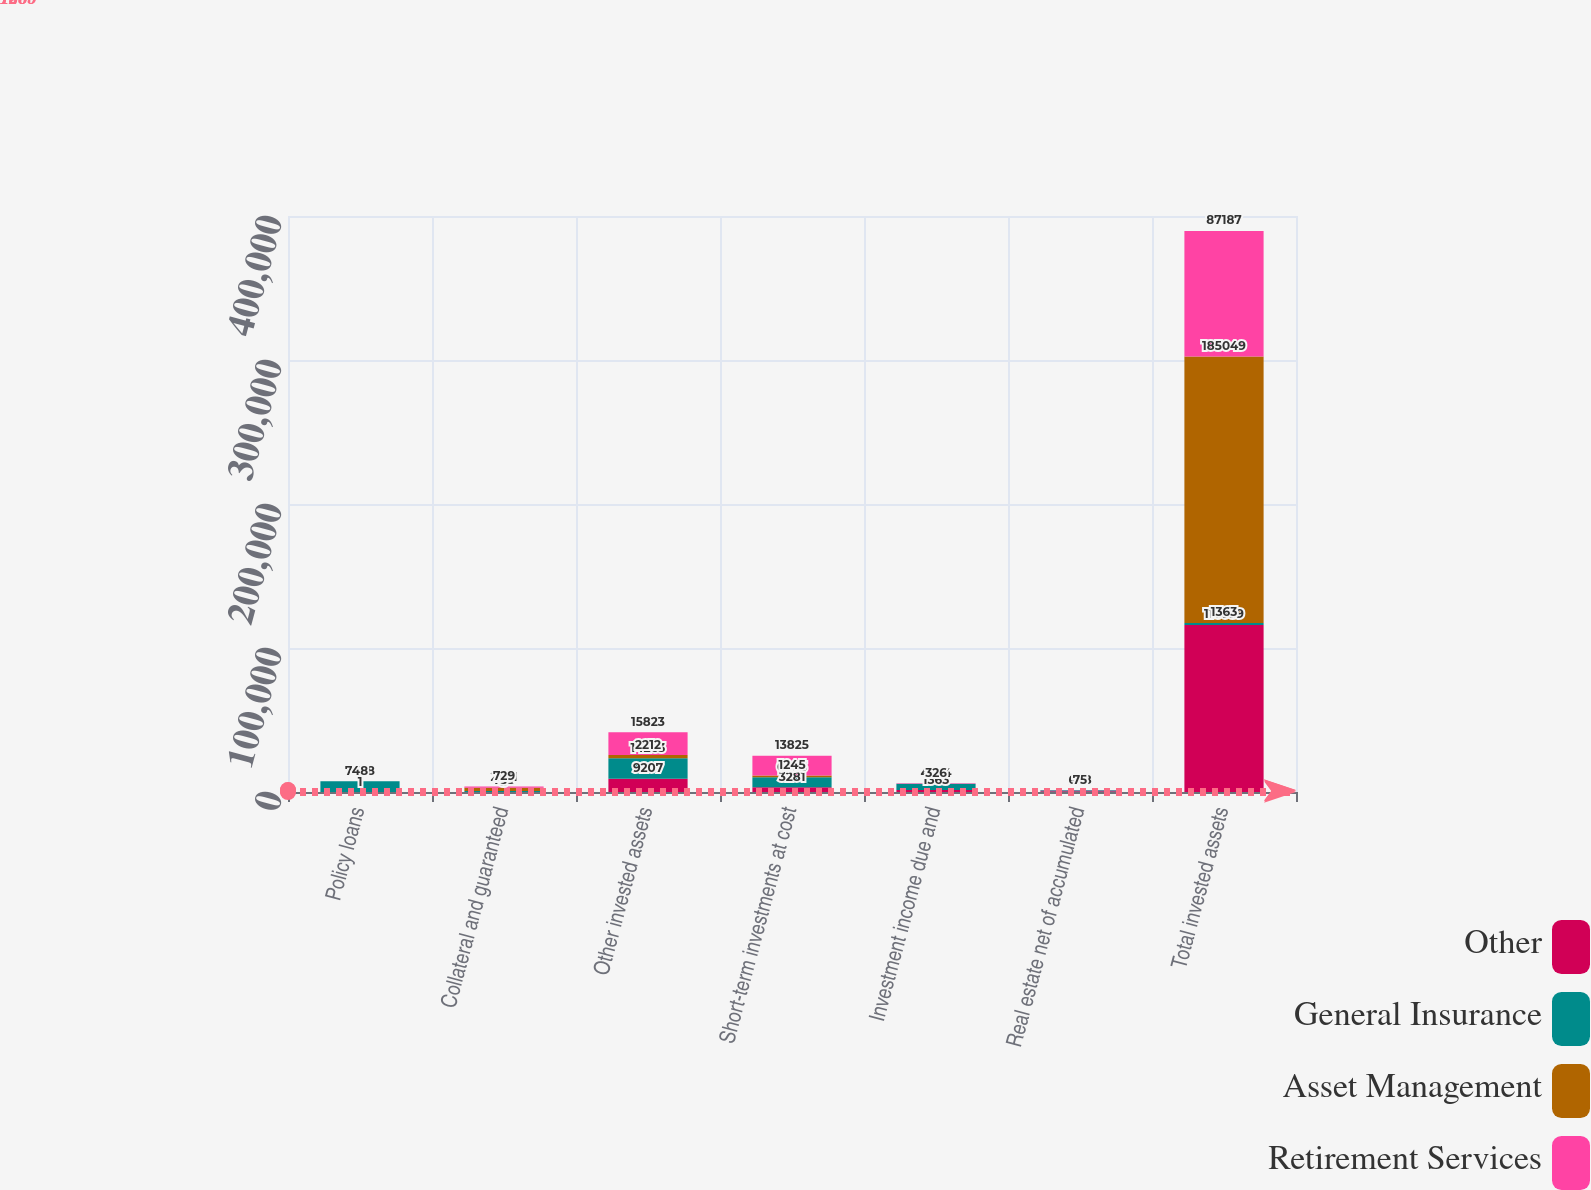Convert chart to OTSL. <chart><loc_0><loc_0><loc_500><loc_500><stacked_bar_chart><ecel><fcel>Policy loans<fcel>Collateral and guaranteed<fcel>Other invested assets<fcel>Short-term investments at cost<fcel>Investment income due and<fcel>Real estate net of accumulated<fcel>Total invested assets<nl><fcel>Other<fcel>1<fcel>3<fcel>9207<fcel>3281<fcel>1363<fcel>570<fcel>116059<nl><fcel>General Insurance<fcel>7458<fcel>733<fcel>14263<fcel>6893<fcel>4364<fcel>698<fcel>1363<nl><fcel>Asset Management<fcel>2<fcel>2301<fcel>2212<fcel>1245<fcel>23<fcel>17<fcel>185049<nl><fcel>Retirement Services<fcel>48<fcel>729<fcel>15823<fcel>13825<fcel>326<fcel>75<fcel>87187<nl></chart> 